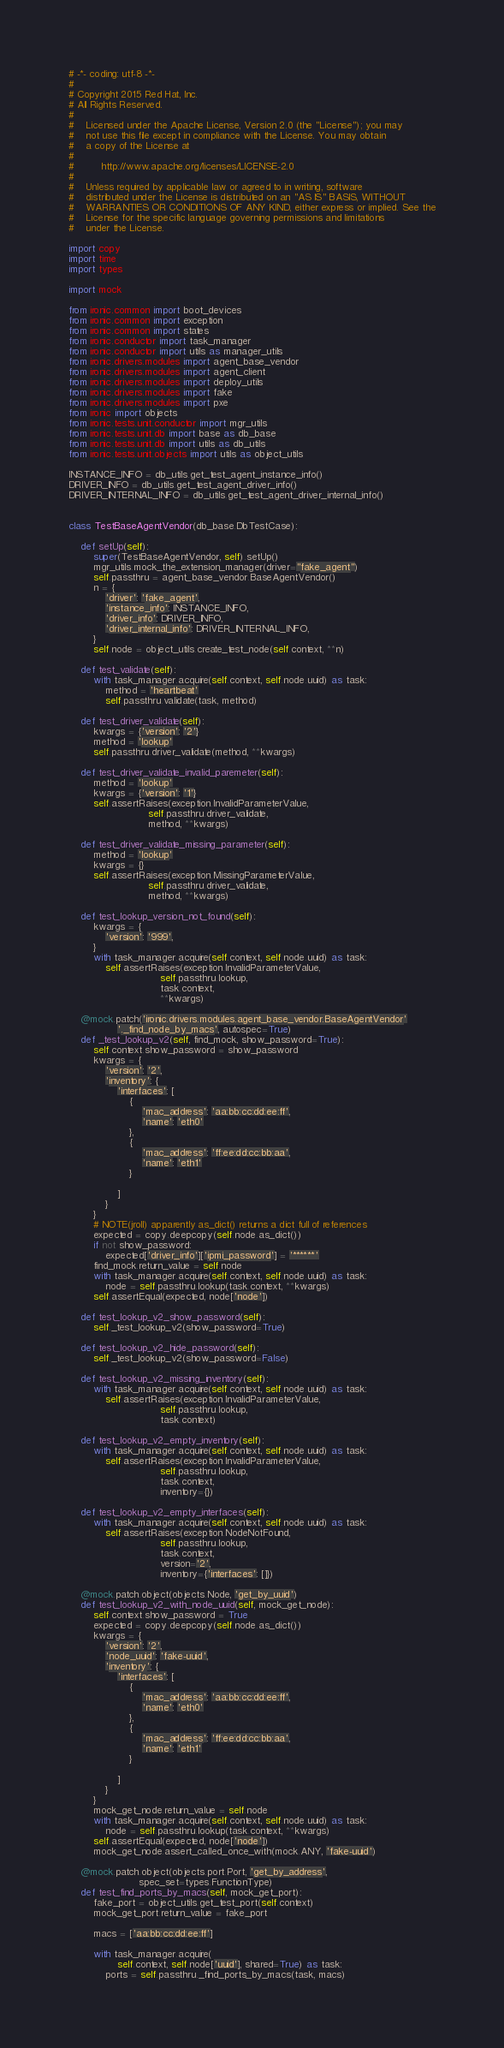Convert code to text. <code><loc_0><loc_0><loc_500><loc_500><_Python_># -*- coding: utf-8 -*-
#
# Copyright 2015 Red Hat, Inc.
# All Rights Reserved.
#
#    Licensed under the Apache License, Version 2.0 (the "License"); you may
#    not use this file except in compliance with the License. You may obtain
#    a copy of the License at
#
#         http://www.apache.org/licenses/LICENSE-2.0
#
#    Unless required by applicable law or agreed to in writing, software
#    distributed under the License is distributed on an "AS IS" BASIS, WITHOUT
#    WARRANTIES OR CONDITIONS OF ANY KIND, either express or implied. See the
#    License for the specific language governing permissions and limitations
#    under the License.

import copy
import time
import types

import mock

from ironic.common import boot_devices
from ironic.common import exception
from ironic.common import states
from ironic.conductor import task_manager
from ironic.conductor import utils as manager_utils
from ironic.drivers.modules import agent_base_vendor
from ironic.drivers.modules import agent_client
from ironic.drivers.modules import deploy_utils
from ironic.drivers.modules import fake
from ironic.drivers.modules import pxe
from ironic import objects
from ironic.tests.unit.conductor import mgr_utils
from ironic.tests.unit.db import base as db_base
from ironic.tests.unit.db import utils as db_utils
from ironic.tests.unit.objects import utils as object_utils

INSTANCE_INFO = db_utils.get_test_agent_instance_info()
DRIVER_INFO = db_utils.get_test_agent_driver_info()
DRIVER_INTERNAL_INFO = db_utils.get_test_agent_driver_internal_info()


class TestBaseAgentVendor(db_base.DbTestCase):

    def setUp(self):
        super(TestBaseAgentVendor, self).setUp()
        mgr_utils.mock_the_extension_manager(driver="fake_agent")
        self.passthru = agent_base_vendor.BaseAgentVendor()
        n = {
            'driver': 'fake_agent',
            'instance_info': INSTANCE_INFO,
            'driver_info': DRIVER_INFO,
            'driver_internal_info': DRIVER_INTERNAL_INFO,
        }
        self.node = object_utils.create_test_node(self.context, **n)

    def test_validate(self):
        with task_manager.acquire(self.context, self.node.uuid) as task:
            method = 'heartbeat'
            self.passthru.validate(task, method)

    def test_driver_validate(self):
        kwargs = {'version': '2'}
        method = 'lookup'
        self.passthru.driver_validate(method, **kwargs)

    def test_driver_validate_invalid_paremeter(self):
        method = 'lookup'
        kwargs = {'version': '1'}
        self.assertRaises(exception.InvalidParameterValue,
                          self.passthru.driver_validate,
                          method, **kwargs)

    def test_driver_validate_missing_parameter(self):
        method = 'lookup'
        kwargs = {}
        self.assertRaises(exception.MissingParameterValue,
                          self.passthru.driver_validate,
                          method, **kwargs)

    def test_lookup_version_not_found(self):
        kwargs = {
            'version': '999',
        }
        with task_manager.acquire(self.context, self.node.uuid) as task:
            self.assertRaises(exception.InvalidParameterValue,
                              self.passthru.lookup,
                              task.context,
                              **kwargs)

    @mock.patch('ironic.drivers.modules.agent_base_vendor.BaseAgentVendor'
                '._find_node_by_macs', autospec=True)
    def _test_lookup_v2(self, find_mock, show_password=True):
        self.context.show_password = show_password
        kwargs = {
            'version': '2',
            'inventory': {
                'interfaces': [
                    {
                        'mac_address': 'aa:bb:cc:dd:ee:ff',
                        'name': 'eth0'
                    },
                    {
                        'mac_address': 'ff:ee:dd:cc:bb:aa',
                        'name': 'eth1'
                    }

                ]
            }
        }
        # NOTE(jroll) apparently as_dict() returns a dict full of references
        expected = copy.deepcopy(self.node.as_dict())
        if not show_password:
            expected['driver_info']['ipmi_password'] = '******'
        find_mock.return_value = self.node
        with task_manager.acquire(self.context, self.node.uuid) as task:
            node = self.passthru.lookup(task.context, **kwargs)
        self.assertEqual(expected, node['node'])

    def test_lookup_v2_show_password(self):
        self._test_lookup_v2(show_password=True)

    def test_lookup_v2_hide_password(self):
        self._test_lookup_v2(show_password=False)

    def test_lookup_v2_missing_inventory(self):
        with task_manager.acquire(self.context, self.node.uuid) as task:
            self.assertRaises(exception.InvalidParameterValue,
                              self.passthru.lookup,
                              task.context)

    def test_lookup_v2_empty_inventory(self):
        with task_manager.acquire(self.context, self.node.uuid) as task:
            self.assertRaises(exception.InvalidParameterValue,
                              self.passthru.lookup,
                              task.context,
                              inventory={})

    def test_lookup_v2_empty_interfaces(self):
        with task_manager.acquire(self.context, self.node.uuid) as task:
            self.assertRaises(exception.NodeNotFound,
                              self.passthru.lookup,
                              task.context,
                              version='2',
                              inventory={'interfaces': []})

    @mock.patch.object(objects.Node, 'get_by_uuid')
    def test_lookup_v2_with_node_uuid(self, mock_get_node):
        self.context.show_password = True
        expected = copy.deepcopy(self.node.as_dict())
        kwargs = {
            'version': '2',
            'node_uuid': 'fake-uuid',
            'inventory': {
                'interfaces': [
                    {
                        'mac_address': 'aa:bb:cc:dd:ee:ff',
                        'name': 'eth0'
                    },
                    {
                        'mac_address': 'ff:ee:dd:cc:bb:aa',
                        'name': 'eth1'
                    }

                ]
            }
        }
        mock_get_node.return_value = self.node
        with task_manager.acquire(self.context, self.node.uuid) as task:
            node = self.passthru.lookup(task.context, **kwargs)
        self.assertEqual(expected, node['node'])
        mock_get_node.assert_called_once_with(mock.ANY, 'fake-uuid')

    @mock.patch.object(objects.port.Port, 'get_by_address',
                       spec_set=types.FunctionType)
    def test_find_ports_by_macs(self, mock_get_port):
        fake_port = object_utils.get_test_port(self.context)
        mock_get_port.return_value = fake_port

        macs = ['aa:bb:cc:dd:ee:ff']

        with task_manager.acquire(
                self.context, self.node['uuid'], shared=True) as task:
            ports = self.passthru._find_ports_by_macs(task, macs)</code> 